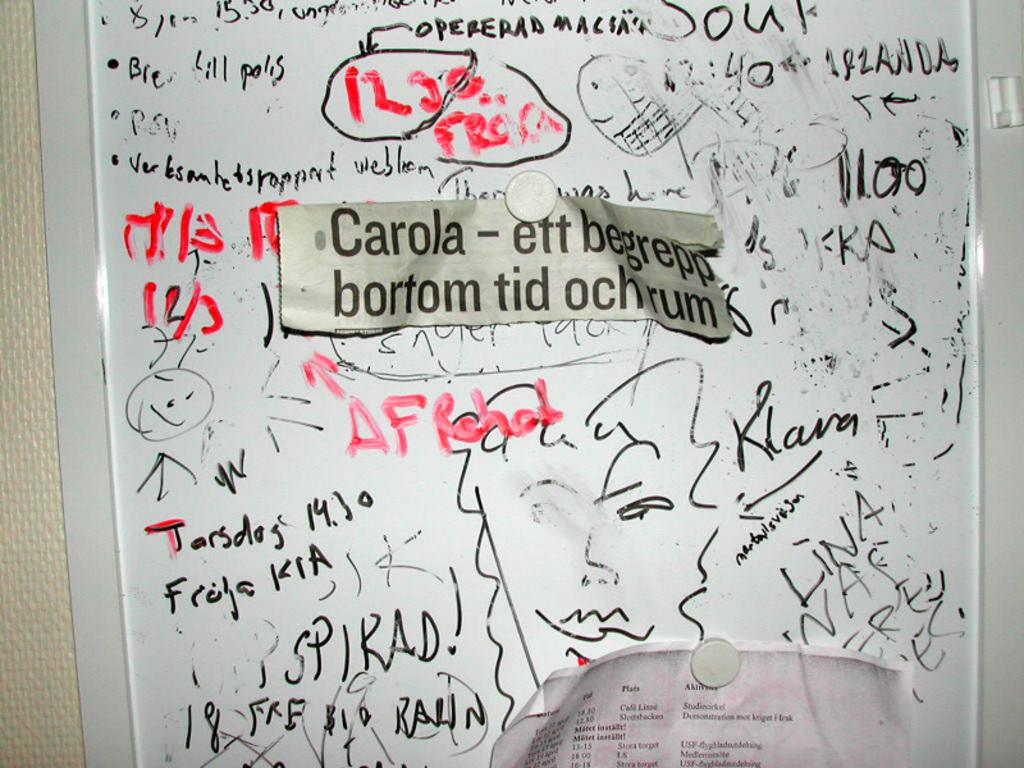Provide a one-sentence caption for the provided image. White board which has a label saying "Carola". 